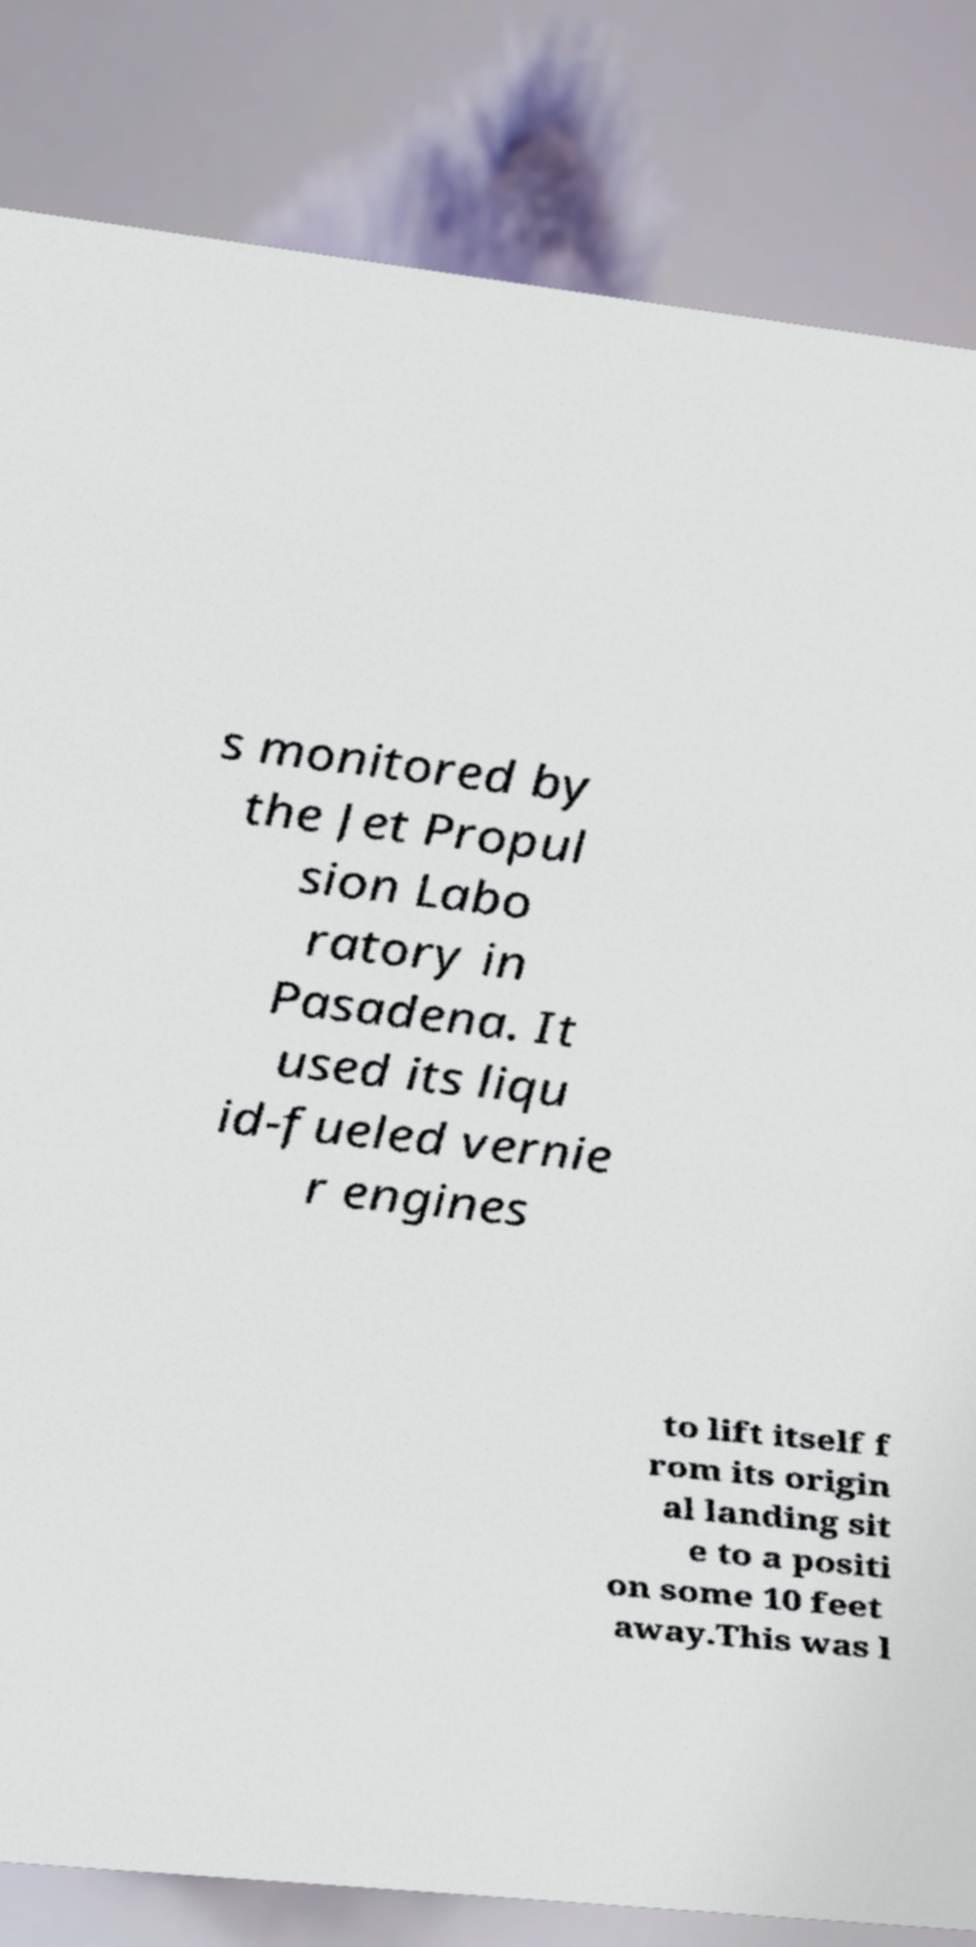Can you read and provide the text displayed in the image?This photo seems to have some interesting text. Can you extract and type it out for me? s monitored by the Jet Propul sion Labo ratory in Pasadena. It used its liqu id-fueled vernie r engines to lift itself f rom its origin al landing sit e to a positi on some 10 feet away.This was l 